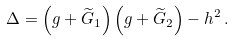Convert formula to latex. <formula><loc_0><loc_0><loc_500><loc_500>\Delta = \left ( g + \widetilde { G } _ { 1 } \right ) \left ( g + \widetilde { G } _ { 2 } \right ) - h ^ { 2 } \, .</formula> 